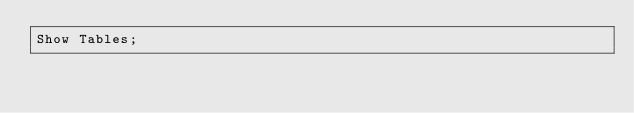Convert code to text. <code><loc_0><loc_0><loc_500><loc_500><_SQL_>Show Tables;</code> 